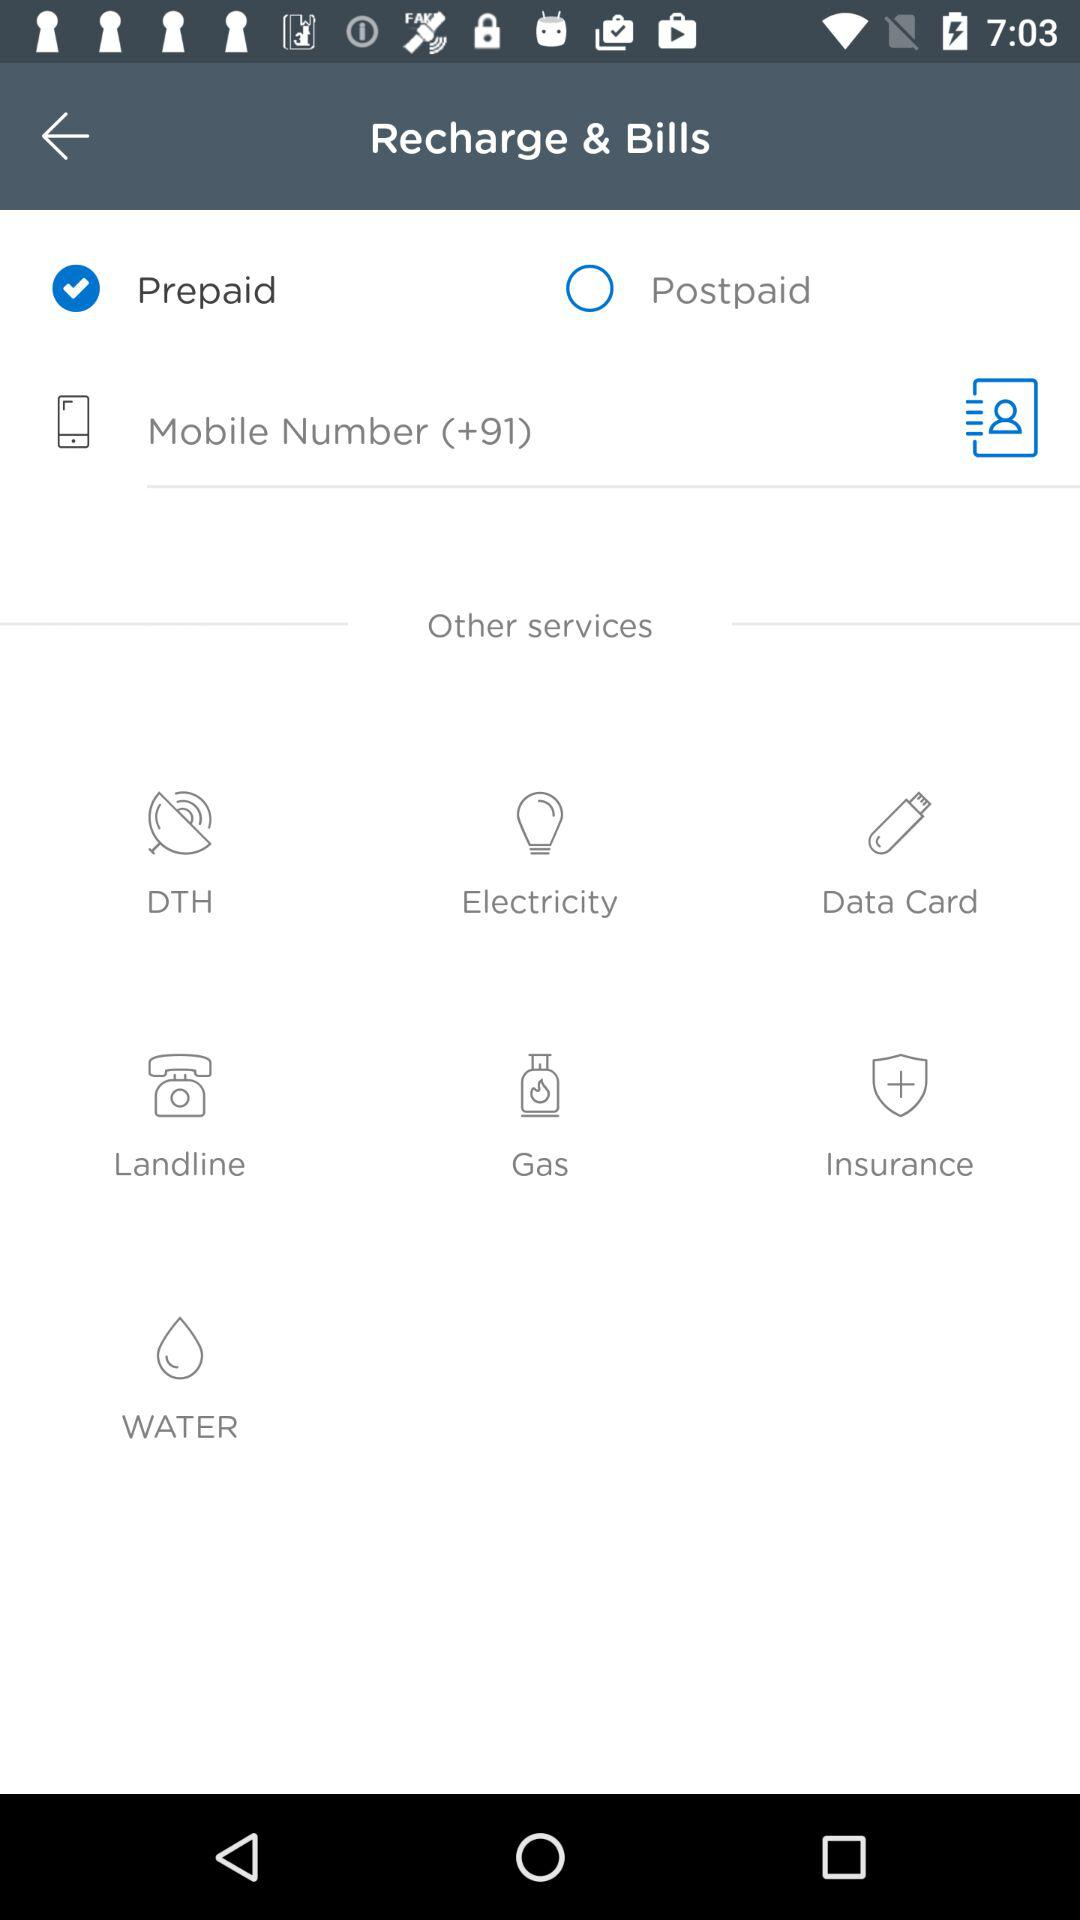What is the country code given? The country code is +91. 